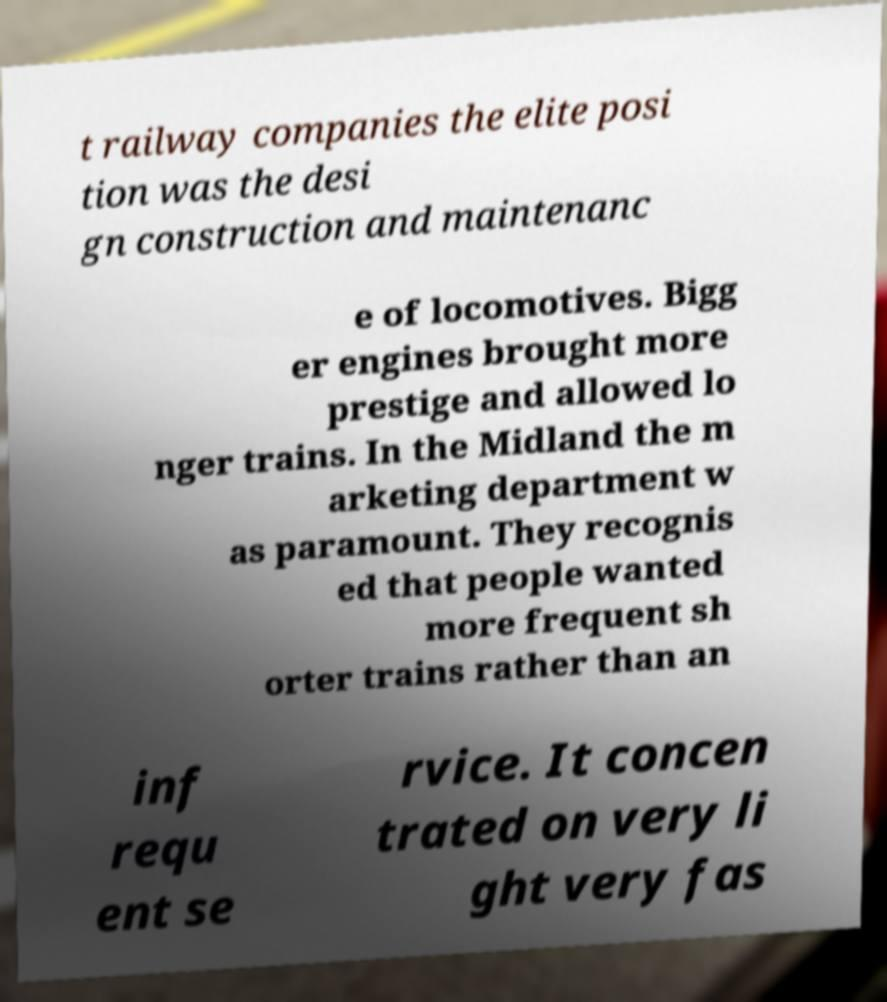Can you read and provide the text displayed in the image?This photo seems to have some interesting text. Can you extract and type it out for me? t railway companies the elite posi tion was the desi gn construction and maintenanc e of locomotives. Bigg er engines brought more prestige and allowed lo nger trains. In the Midland the m arketing department w as paramount. They recognis ed that people wanted more frequent sh orter trains rather than an inf requ ent se rvice. It concen trated on very li ght very fas 